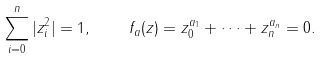<formula> <loc_0><loc_0><loc_500><loc_500>\sum _ { i = 0 } ^ { n } | z _ { i } ^ { 2 } | = 1 , \quad f _ { a } ( z ) = z _ { 0 } ^ { a _ { 1 } } + \cdots + z _ { n } ^ { a _ { n } } = 0 .</formula> 